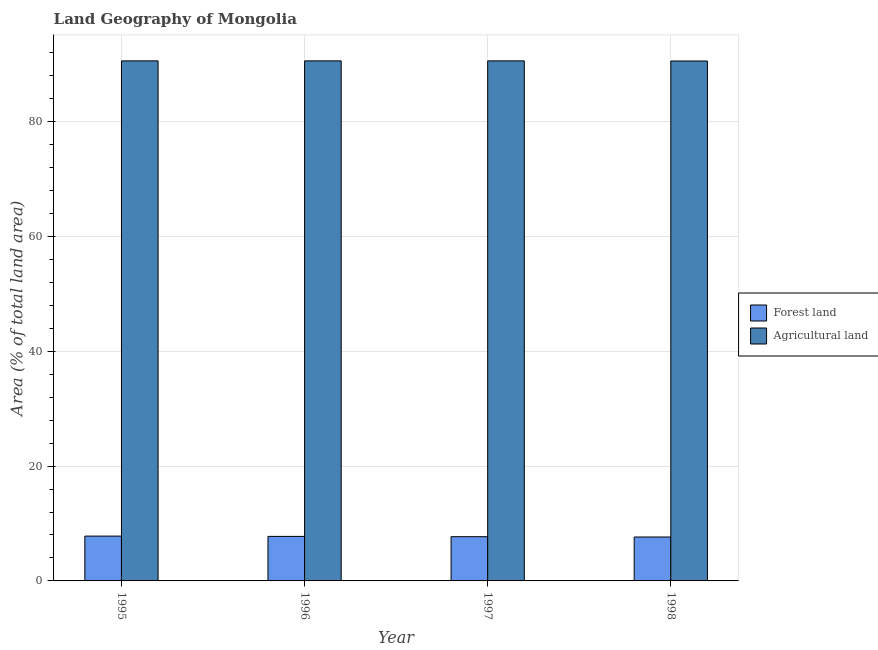Are the number of bars per tick equal to the number of legend labels?
Offer a terse response. Yes. How many bars are there on the 3rd tick from the left?
Offer a very short reply. 2. What is the label of the 1st group of bars from the left?
Offer a very short reply. 1995. In how many cases, is the number of bars for a given year not equal to the number of legend labels?
Offer a terse response. 0. What is the percentage of land area under forests in 1996?
Provide a short and direct response. 7.75. Across all years, what is the maximum percentage of land area under agriculture?
Provide a succinct answer. 90.56. Across all years, what is the minimum percentage of land area under agriculture?
Give a very brief answer. 90.54. In which year was the percentage of land area under forests maximum?
Give a very brief answer. 1995. In which year was the percentage of land area under agriculture minimum?
Your response must be concise. 1998. What is the total percentage of land area under agriculture in the graph?
Your answer should be very brief. 362.2. What is the difference between the percentage of land area under forests in 1997 and that in 1998?
Keep it short and to the point. 0.05. What is the average percentage of land area under agriculture per year?
Offer a very short reply. 90.55. In how many years, is the percentage of land area under agriculture greater than 28 %?
Keep it short and to the point. 4. What is the ratio of the percentage of land area under forests in 1995 to that in 1996?
Offer a terse response. 1.01. Is the difference between the percentage of land area under agriculture in 1995 and 1996 greater than the difference between the percentage of land area under forests in 1995 and 1996?
Ensure brevity in your answer.  No. What is the difference between the highest and the second highest percentage of land area under agriculture?
Keep it short and to the point. 0. What is the difference between the highest and the lowest percentage of land area under forests?
Your response must be concise. 0.16. In how many years, is the percentage of land area under forests greater than the average percentage of land area under forests taken over all years?
Your answer should be compact. 2. What does the 2nd bar from the left in 1998 represents?
Ensure brevity in your answer.  Agricultural land. What does the 2nd bar from the right in 1998 represents?
Your answer should be compact. Forest land. How many bars are there?
Make the answer very short. 8. Are all the bars in the graph horizontal?
Offer a terse response. No. Are the values on the major ticks of Y-axis written in scientific E-notation?
Give a very brief answer. No. Does the graph contain any zero values?
Your answer should be very brief. No. How are the legend labels stacked?
Provide a short and direct response. Vertical. What is the title of the graph?
Make the answer very short. Land Geography of Mongolia. Does "Unregistered firms" appear as one of the legend labels in the graph?
Provide a succinct answer. No. What is the label or title of the Y-axis?
Ensure brevity in your answer.  Area (% of total land area). What is the Area (% of total land area) of Forest land in 1995?
Keep it short and to the point. 7.81. What is the Area (% of total land area) in Agricultural land in 1995?
Provide a succinct answer. 90.56. What is the Area (% of total land area) of Forest land in 1996?
Your response must be concise. 7.75. What is the Area (% of total land area) in Agricultural land in 1996?
Your answer should be compact. 90.56. What is the Area (% of total land area) in Forest land in 1997?
Offer a terse response. 7.7. What is the Area (% of total land area) in Agricultural land in 1997?
Offer a terse response. 90.56. What is the Area (% of total land area) of Forest land in 1998?
Ensure brevity in your answer.  7.65. What is the Area (% of total land area) of Agricultural land in 1998?
Provide a succinct answer. 90.54. Across all years, what is the maximum Area (% of total land area) in Forest land?
Ensure brevity in your answer.  7.81. Across all years, what is the maximum Area (% of total land area) in Agricultural land?
Your response must be concise. 90.56. Across all years, what is the minimum Area (% of total land area) in Forest land?
Make the answer very short. 7.65. Across all years, what is the minimum Area (% of total land area) of Agricultural land?
Offer a terse response. 90.54. What is the total Area (% of total land area) in Forest land in the graph?
Your answer should be very brief. 30.91. What is the total Area (% of total land area) in Agricultural land in the graph?
Your response must be concise. 362.2. What is the difference between the Area (% of total land area) of Forest land in 1995 and that in 1996?
Offer a terse response. 0.05. What is the difference between the Area (% of total land area) in Forest land in 1995 and that in 1997?
Keep it short and to the point. 0.11. What is the difference between the Area (% of total land area) of Agricultural land in 1995 and that in 1997?
Offer a terse response. 0. What is the difference between the Area (% of total land area) of Forest land in 1995 and that in 1998?
Your answer should be compact. 0.16. What is the difference between the Area (% of total land area) in Forest land in 1996 and that in 1997?
Make the answer very short. 0.05. What is the difference between the Area (% of total land area) in Forest land in 1996 and that in 1998?
Offer a terse response. 0.11. What is the difference between the Area (% of total land area) in Forest land in 1997 and that in 1998?
Your answer should be compact. 0.05. What is the difference between the Area (% of total land area) in Forest land in 1995 and the Area (% of total land area) in Agricultural land in 1996?
Provide a short and direct response. -82.75. What is the difference between the Area (% of total land area) of Forest land in 1995 and the Area (% of total land area) of Agricultural land in 1997?
Your answer should be compact. -82.75. What is the difference between the Area (% of total land area) in Forest land in 1995 and the Area (% of total land area) in Agricultural land in 1998?
Provide a succinct answer. -82.73. What is the difference between the Area (% of total land area) of Forest land in 1996 and the Area (% of total land area) of Agricultural land in 1997?
Offer a very short reply. -82.8. What is the difference between the Area (% of total land area) of Forest land in 1996 and the Area (% of total land area) of Agricultural land in 1998?
Your answer should be compact. -82.78. What is the difference between the Area (% of total land area) in Forest land in 1997 and the Area (% of total land area) in Agricultural land in 1998?
Keep it short and to the point. -82.84. What is the average Area (% of total land area) of Forest land per year?
Your answer should be compact. 7.73. What is the average Area (% of total land area) in Agricultural land per year?
Offer a very short reply. 90.55. In the year 1995, what is the difference between the Area (% of total land area) in Forest land and Area (% of total land area) in Agricultural land?
Make the answer very short. -82.75. In the year 1996, what is the difference between the Area (% of total land area) of Forest land and Area (% of total land area) of Agricultural land?
Give a very brief answer. -82.8. In the year 1997, what is the difference between the Area (% of total land area) in Forest land and Area (% of total land area) in Agricultural land?
Offer a very short reply. -82.86. In the year 1998, what is the difference between the Area (% of total land area) of Forest land and Area (% of total land area) of Agricultural land?
Your answer should be compact. -82.89. What is the ratio of the Area (% of total land area) of Forest land in 1995 to that in 1996?
Give a very brief answer. 1.01. What is the ratio of the Area (% of total land area) in Forest land in 1995 to that in 1997?
Keep it short and to the point. 1.01. What is the ratio of the Area (% of total land area) of Agricultural land in 1995 to that in 1997?
Make the answer very short. 1. What is the ratio of the Area (% of total land area) of Forest land in 1995 to that in 1998?
Provide a succinct answer. 1.02. What is the ratio of the Area (% of total land area) of Forest land in 1996 to that in 1997?
Provide a short and direct response. 1.01. What is the ratio of the Area (% of total land area) in Forest land in 1996 to that in 1998?
Your response must be concise. 1.01. What is the ratio of the Area (% of total land area) in Agricultural land in 1996 to that in 1998?
Your response must be concise. 1. What is the ratio of the Area (% of total land area) of Forest land in 1997 to that in 1998?
Offer a terse response. 1.01. What is the difference between the highest and the second highest Area (% of total land area) of Forest land?
Ensure brevity in your answer.  0.05. What is the difference between the highest and the lowest Area (% of total land area) of Forest land?
Your answer should be compact. 0.16. What is the difference between the highest and the lowest Area (% of total land area) in Agricultural land?
Give a very brief answer. 0.02. 